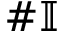<formula> <loc_0><loc_0><loc_500><loc_500>\# \mathbb { I }</formula> 